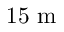<formula> <loc_0><loc_0><loc_500><loc_500>1 5 m</formula> 